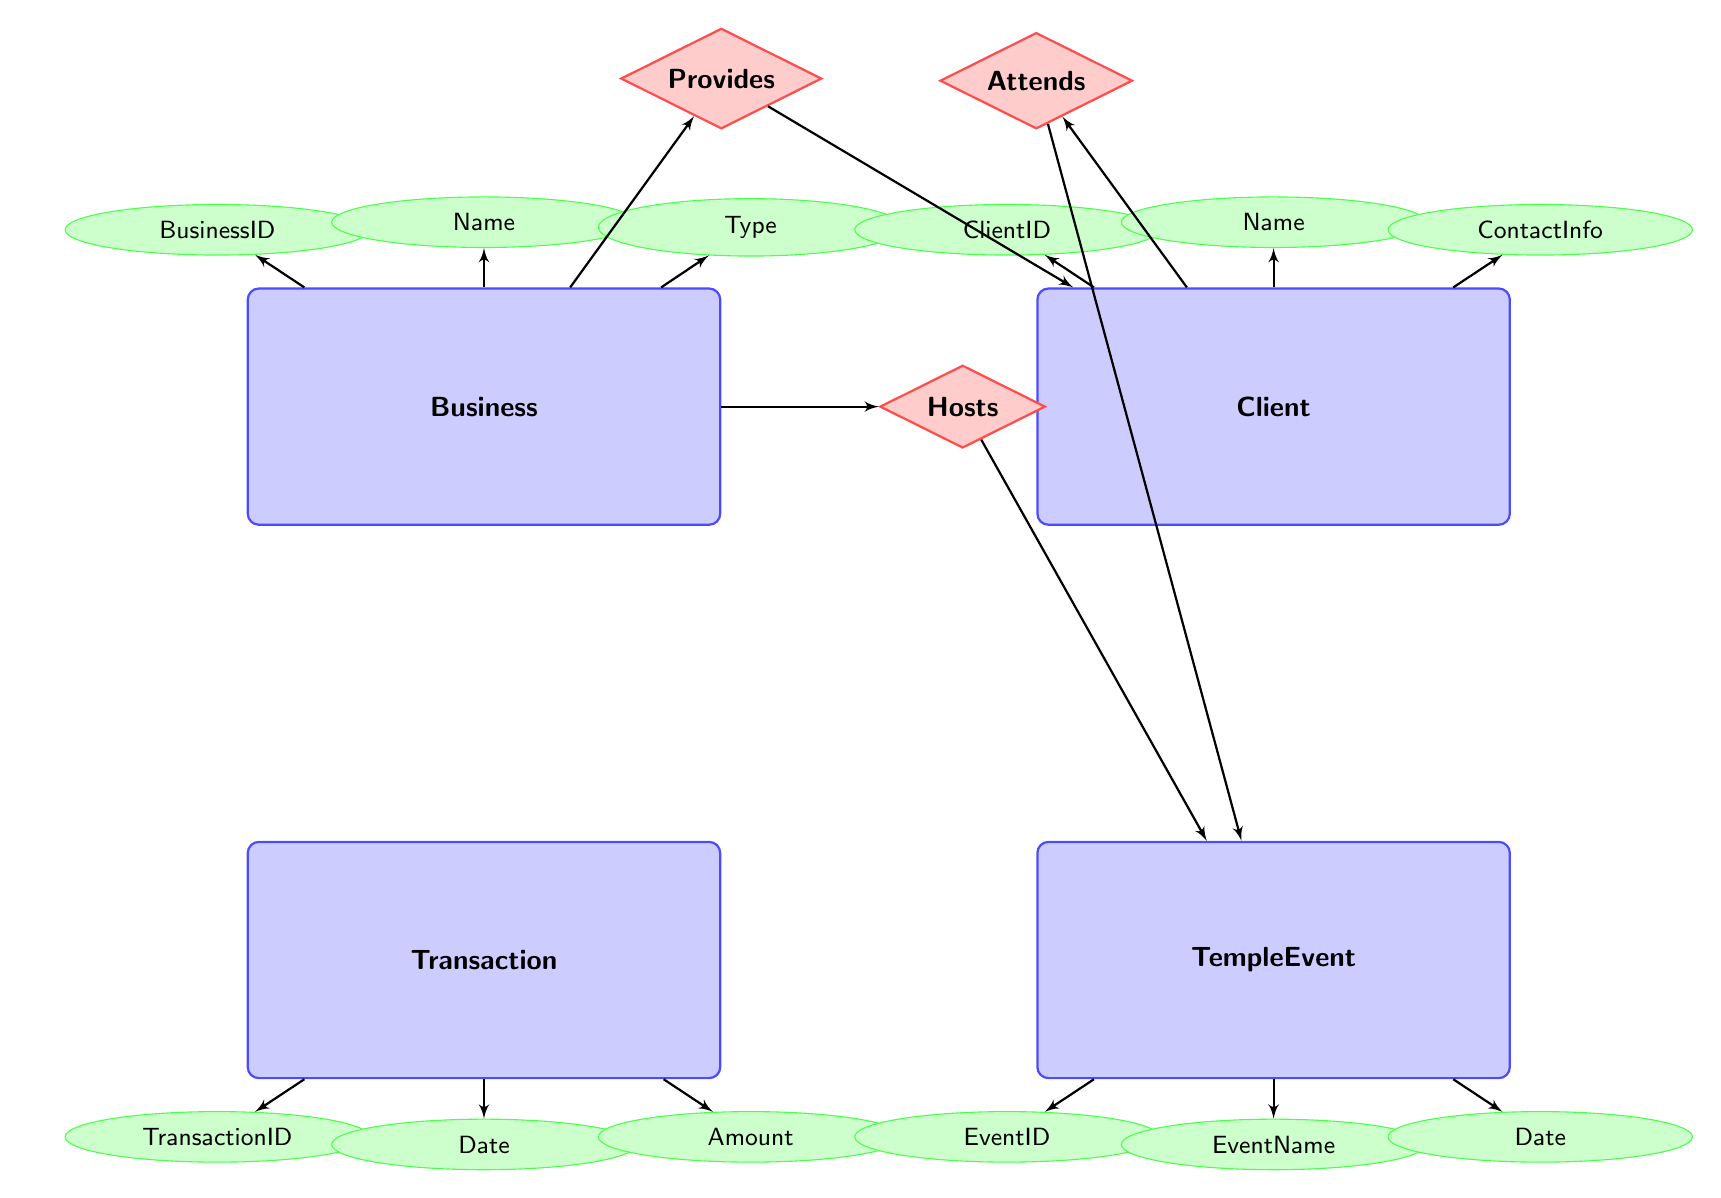What attributes does the Business entity have? The Business entity has attributes listed as BusinessID, Name, Type, and Location. These attributes are connected directly to the Business node in the diagram.
Answer: BusinessID, Name, Type, Location How many entities are there in the diagram? Counting the nodes labeled "Business," "Client," "Transaction," "TempleEvent," and "Participation," we find there are a total of five entities.
Answer: 5 What relationship connects Business and Client? The relationship that connects Business and Client is labeled "Provides." This is indicated by the diamond shape between the two entities in the diagram.
Answer: Provides Which entity has the attribute ContactInfo? The attribute ContactInfo is associated with the Client entity, as it is linked directly to the Client node in the diagram.
Answer: Client Which event is hosted by the Business entity? The diagram suggests that all TempleEvents related to a Business are hosted through the "Hosts" relationship. However, the specific names of events are not listed in the diagram.
Answer: TempleEvent How do Clients participate in TempleEvents? Clients participate in TempleEvents through the "Attends" relationship, which connects the Client entity to the TempleEvent entity. This shows how clients are linked to events they attend.
Answer: Attends What is the significance of the Participation entity? The Participation entity serves to show the relationship between Clients and TempleEvents they attend, tracked by the ParticipationID and linking ClientID with EventID.
Answer: Links participation What kind of services does the Business provide to Clients? The specific details of services are contained in the "ServiceDetails" attribute part of the "Provides" relationship between Business and Client, indicating the nature of the relationship.
Answer: ServiceDetails How is a Transaction related to a Client? A Transaction is related to a Client via the ClientID attribute, which links the Transaction entity directly to the Client entity within the diagram.
Answer: ClientID 